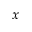<formula> <loc_0><loc_0><loc_500><loc_500>x</formula> 